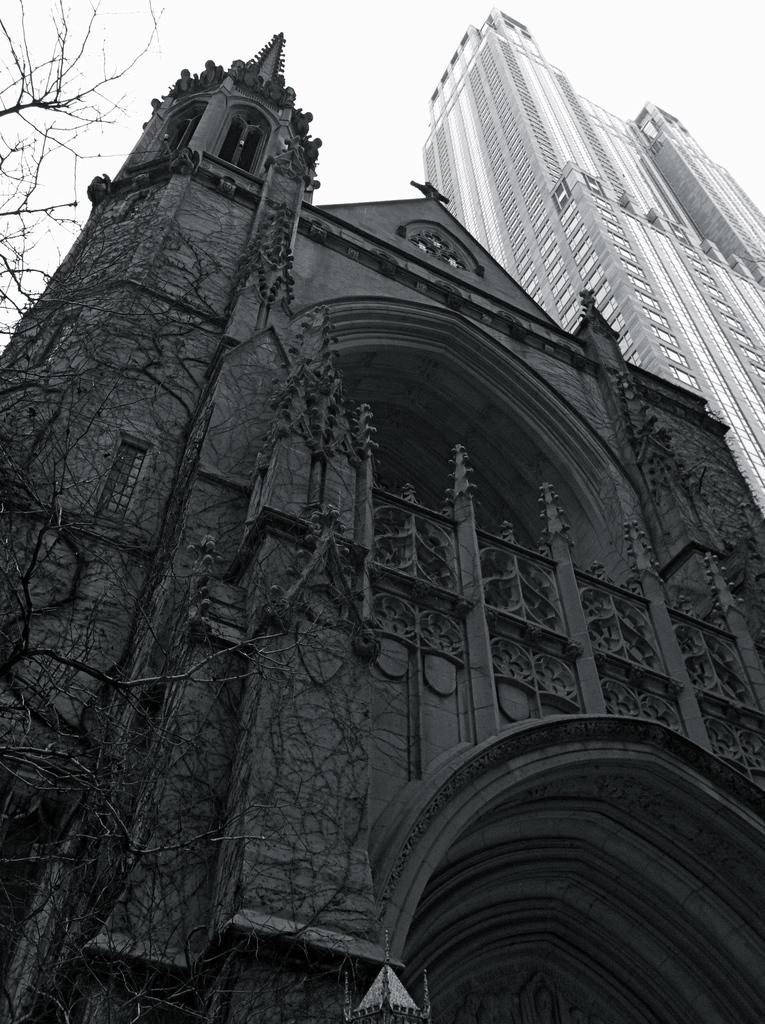What is located in the center of the image? There are buildings in the center of the image. What type of vegetation can be seen in the image? There are trees in the image. What is visible at the top of the image? The sky is visible at the top of the image. Can you see any rice being cooked in the image? There is no rice or cooking activity present in the image. Is there a dog playing volleyball in the image? There is no dog or volleyball present in the image. 